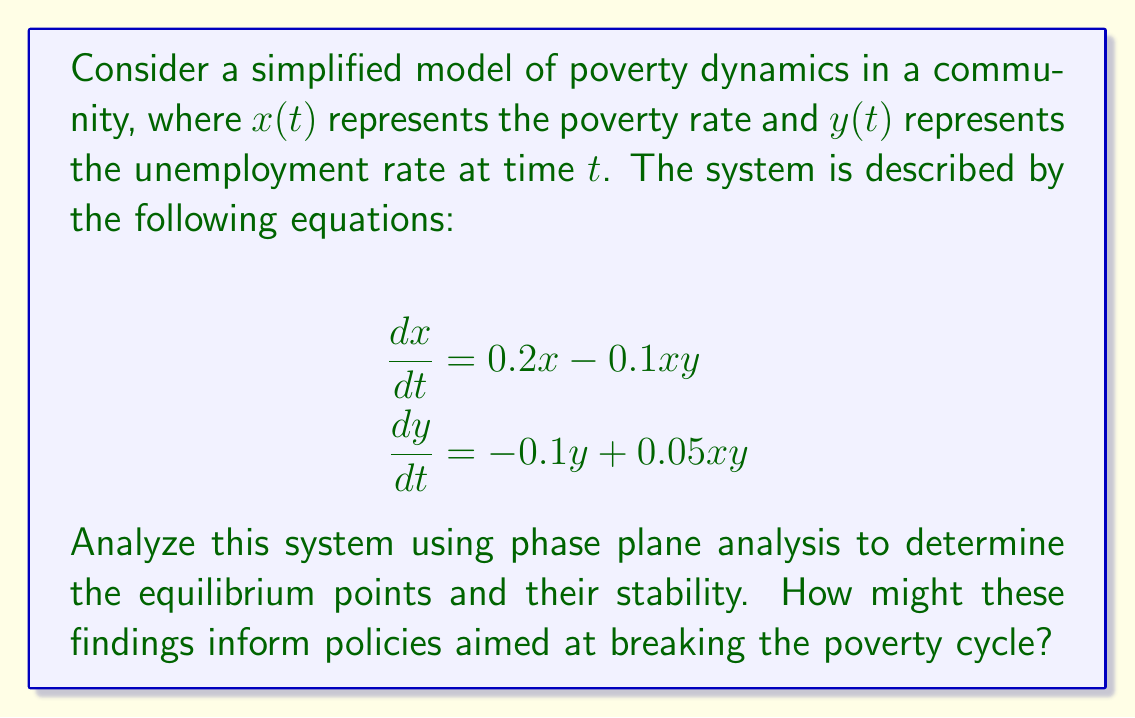Can you answer this question? To analyze this system using phase plane analysis, we'll follow these steps:

1. Find the equilibrium points by setting $\frac{dx}{dt} = 0$ and $\frac{dy}{dt} = 0$:

   $0.2x - 0.1xy = 0$
   $-0.1y + 0.05xy = 0$

2. Solve these equations:
   From the first equation: $x(0.2 - 0.1y) = 0$, so $x = 0$ or $y = 2$
   From the second equation: $y(-0.1 + 0.05x) = 0$, so $y = 0$ or $x = 2$

   This gives us three equilibrium points: $(0,0)$, $(2,0)$, and $(2,2)$

3. Analyze the stability of each equilibrium point by finding the Jacobian matrix:

   $$J = \begin{bmatrix}
   \frac{\partial}{\partial x}(0.2x - 0.1xy) & \frac{\partial}{\partial y}(0.2x - 0.1xy) \\
   \frac{\partial}{\partial x}(-0.1y + 0.05xy) & \frac{\partial}{\partial y}(-0.1y + 0.05xy)
   \end{bmatrix}
   = \begin{bmatrix}
   0.2 - 0.1y & -0.1x \\
   0.05y & -0.1 + 0.05x
   \end{bmatrix}$$

4. Evaluate the Jacobian at each equilibrium point:

   At $(0,0)$: $J_{(0,0)} = \begin{bmatrix} 0.2 & 0 \\ 0 & -0.1 \end{bmatrix}$
   Eigenvalues: $\lambda_1 = 0.2$, $\lambda_2 = -0.1$
   This is a saddle point (unstable)

   At $(2,0)$: $J_{(2,0)} = \begin{bmatrix} 0.2 & -0.2 \\ 0 & 0 \end{bmatrix}$
   Eigenvalues: $\lambda_1 = 0.2$, $\lambda_2 = 0$
   This is a non-hyperbolic equilibrium point (further analysis needed)

   At $(2,2)$: $J_{(2,2)} = \begin{bmatrix} 0 & -0.2 \\ 0.1 & 0 \end{bmatrix}$
   Eigenvalues: $\lambda_{1,2} = \pm 0.1414i$
   This is a center (neutrally stable)

5. Interpret the results:
   - The origin $(0,0)$ represents a state with no poverty or unemployment, but it's unstable.
   - $(2,0)$ represents high poverty with no unemployment, which is non-hyperbolic.
   - $(2,2)$ represents high poverty and high unemployment, forming a neutrally stable cycle.

These findings suggest that the poverty-unemployment system tends to fall into a cycle of high poverty and high unemployment. To break this cycle, policies should aim to:

1. Push the system away from the $(2,2)$ equilibrium by simultaneously addressing both poverty and unemployment.
2. Create interventions that change the system dynamics, potentially altering the equations to introduce a stable equilibrium at lower poverty and unemployment rates.
3. Focus on programs that provide both economic opportunities (to reduce unemployment) and social support (to alleviate poverty) simultaneously.
Answer: The system has three equilibrium points: $(0,0)$ (unstable saddle), $(2,0)$ (non-hyperbolic), and $(2,2)$ (neutrally stable center). Policies should aim to disrupt the high poverty-unemployment cycle and alter system dynamics to create stable low poverty-unemployment states. 